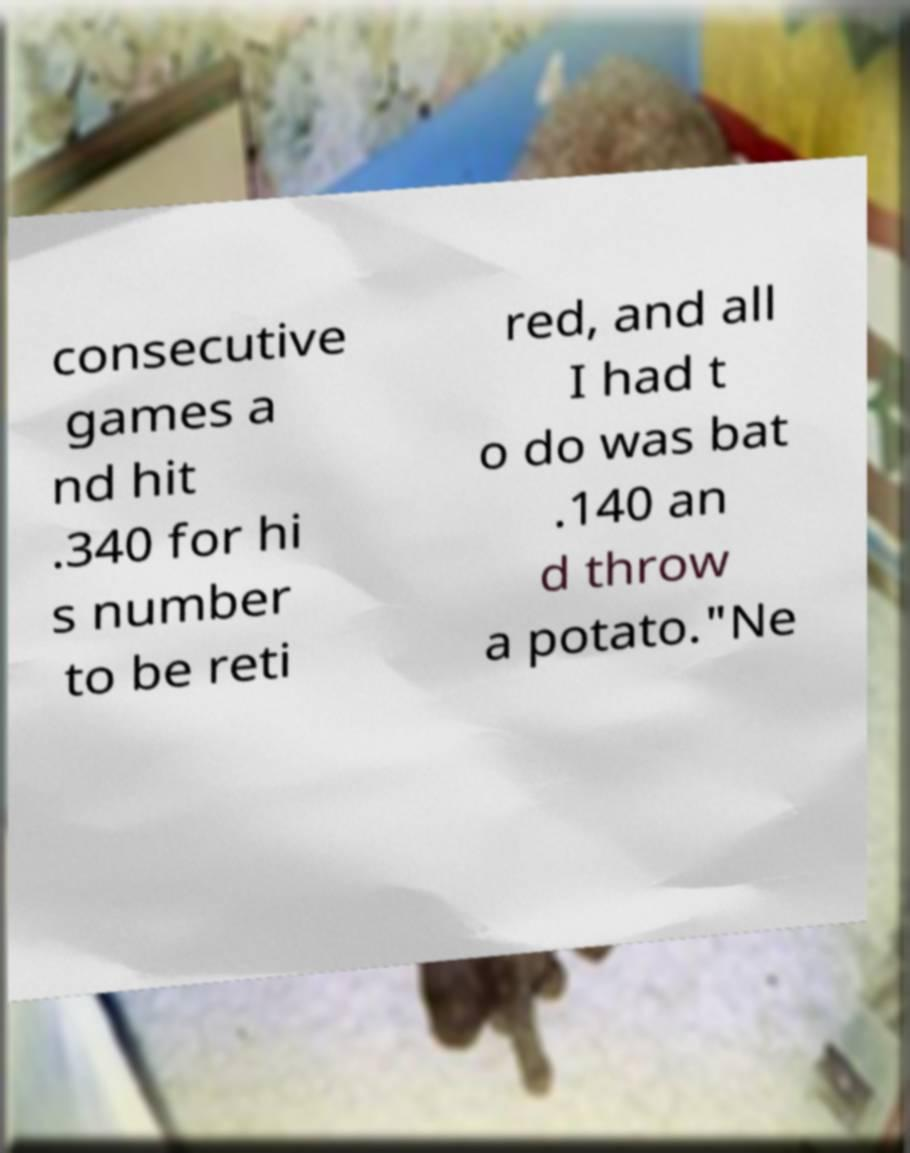For documentation purposes, I need the text within this image transcribed. Could you provide that? consecutive games a nd hit .340 for hi s number to be reti red, and all I had t o do was bat .140 an d throw a potato."Ne 